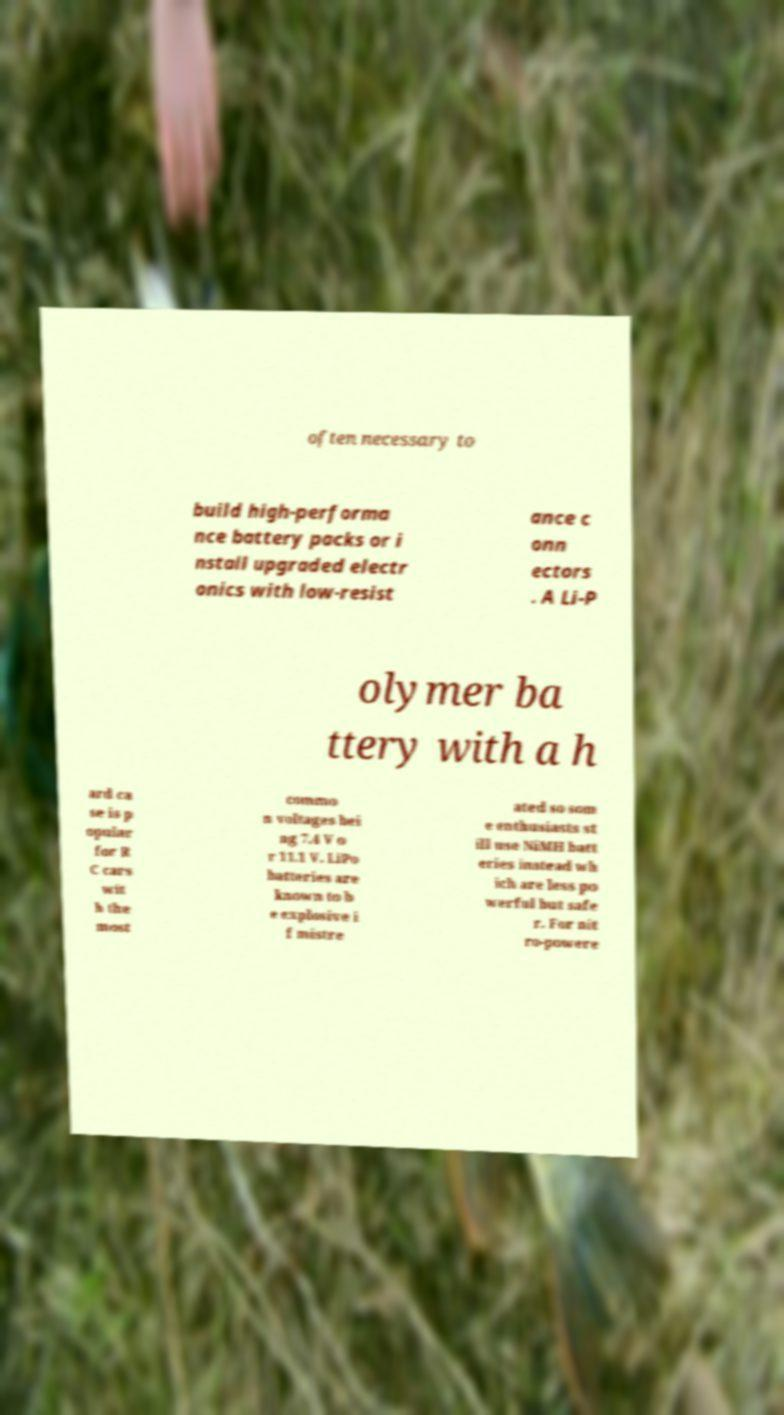Could you assist in decoding the text presented in this image and type it out clearly? often necessary to build high-performa nce battery packs or i nstall upgraded electr onics with low-resist ance c onn ectors . A Li-P olymer ba ttery with a h ard ca se is p opular for R C cars wit h the most commo n voltages bei ng 7.4 V o r 11.1 V. LiPo batteries are known to b e explosive i f mistre ated so som e enthusiasts st ill use NiMH batt eries instead wh ich are less po werful but safe r. For nit ro-powere 